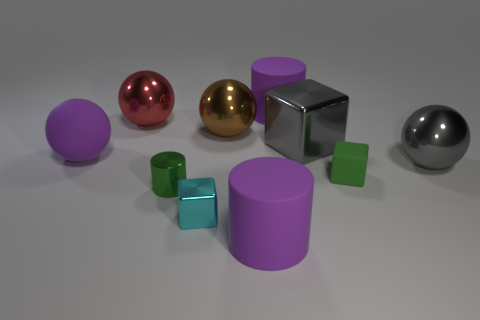Is the color of the thing right of the tiny matte cube the same as the large block?
Keep it short and to the point. Yes. Is the gray block made of the same material as the green cube?
Provide a short and direct response. No. Are there an equal number of small green rubber cubes that are behind the red object and big gray blocks that are on the left side of the cyan metal object?
Keep it short and to the point. Yes. There is another small thing that is the same shape as the tiny cyan metal thing; what is it made of?
Provide a succinct answer. Rubber. What is the shape of the big purple rubber object behind the big purple object that is left of the shiny thing that is in front of the small green shiny cylinder?
Your answer should be very brief. Cylinder. Are there more large purple things on the left side of the red metal ball than cyan matte cylinders?
Offer a terse response. Yes. There is a gray object behind the large purple matte sphere; is it the same shape as the big red metal object?
Keep it short and to the point. No. What material is the big purple cylinder that is behind the small green shiny object?
Keep it short and to the point. Rubber. How many gray things have the same shape as the cyan thing?
Provide a succinct answer. 1. There is a large red sphere left of the cylinder that is behind the red metal ball; what is its material?
Your answer should be very brief. Metal. 